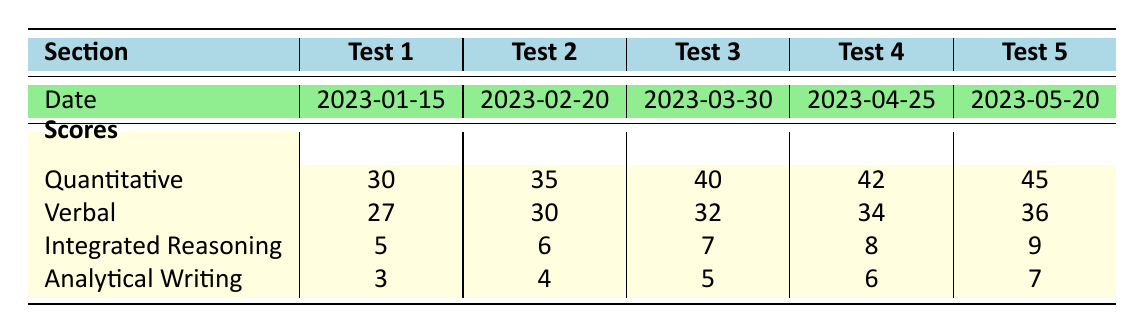What is the highest score in the Quantitative section? The highest score in the Quantitative section is found by looking at the scores across all tests. The scores are 30, 35, 40, 42, and 45. The maximum value among these scores is 45.
Answer: 45 What was the score in the Verbal section on Test 3? The score in the Verbal section for Test 3 is directly provided in the table. It shows a value of 32 for Test 3.
Answer: 32 Which test date had the lowest Analytical Writing score? To determine the lowest Analytical Writing score, we review the scores listed: 3, 4, 5, 6, and 7 for the respective tests. The lowest score is 3, which corresponds to Test 1 on the date 2023-01-15.
Answer: 2023-01-15 What is the average score for Integrated Reasoning across all tests? To find the average score for Integrated Reasoning, we sum the scores (5 + 6 + 7 + 8 + 9) = 35, then divide by the number of tests (5). This results in an average of 35 / 5 = 7.
Answer: 7 Did the Verbal scores improve from Test 1 to Test 5? We examine the Verbal scores from Test 1 (27) to Test 5 (36). Since 36 is greater than 27, this indicates an improvement in the Verbal scores over the tests.
Answer: Yes Which section had the maximum improvement from Test 1 to Test 5? We calculate the improvement for each section: Quantitative improved by (45 - 30) = 15, Verbal by (36 - 27) = 9, Integrated Reasoning by (9 - 5) = 4, and Analytical Writing by (7 - 3) = 4. The greatest improvement is 15 in the Quantitative section.
Answer: Quantitative Which test had the highest score in the Integrated Reasoning section? By inspecting the Integrated Reasoning scores (5, 6, 7, 8, 9), the highest score is 9, which corresponds to Test 5.
Answer: Test 5 What was the score for Analytical Writing in Test 4? The score for Analytical Writing in Test 4 is provided directly in the table. It shows a value of 6 for Test 4.
Answer: 6 How many tests had a Verbal score of 30 or higher? The Verbal scores are listed as 27, 30, 32, 34, and 36. The scores of 30, 32, 34, and 36 are 4 scores that meet this criterion.
Answer: 4 